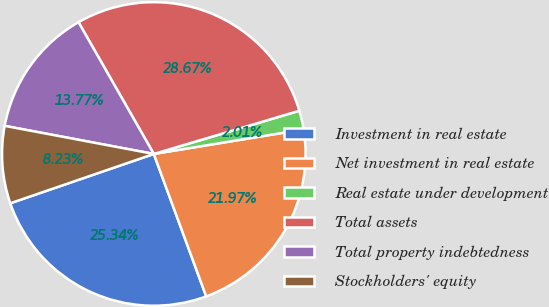<chart> <loc_0><loc_0><loc_500><loc_500><pie_chart><fcel>Investment in real estate<fcel>Net investment in real estate<fcel>Real estate under development<fcel>Total assets<fcel>Total property indebtedness<fcel>Stockholders' equity<nl><fcel>25.34%<fcel>21.97%<fcel>2.01%<fcel>28.67%<fcel>13.77%<fcel>8.23%<nl></chart> 